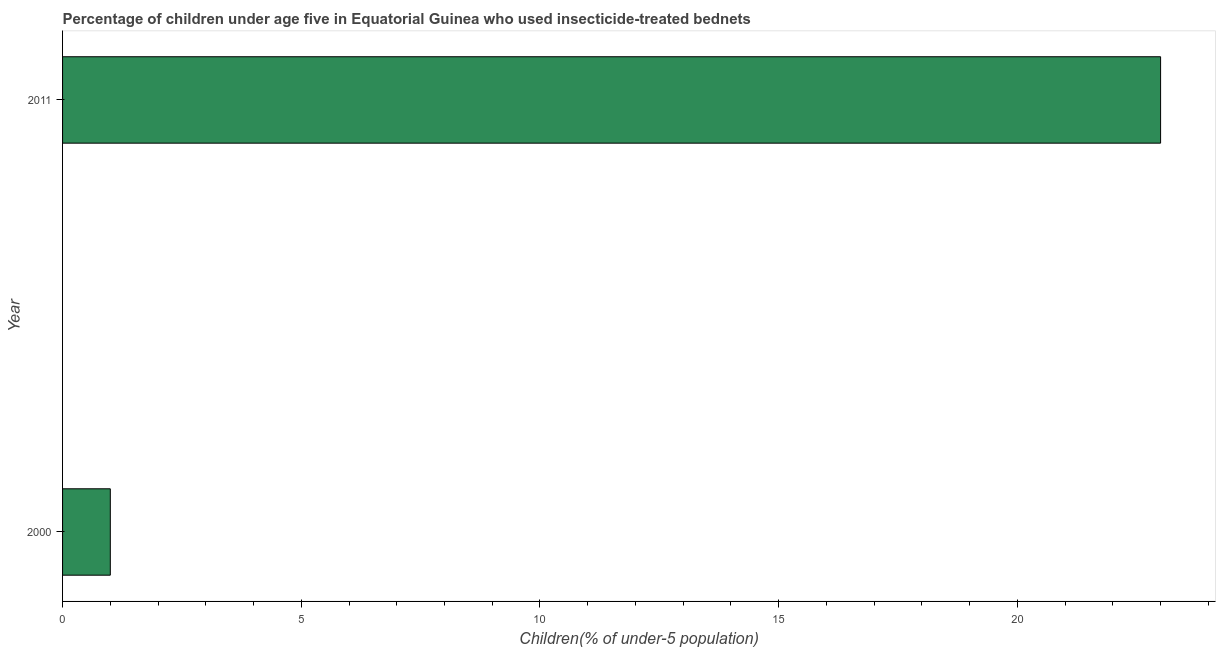What is the title of the graph?
Keep it short and to the point. Percentage of children under age five in Equatorial Guinea who used insecticide-treated bednets. What is the label or title of the X-axis?
Provide a succinct answer. Children(% of under-5 population). What is the percentage of children who use of insecticide-treated bed nets in 2000?
Your answer should be compact. 1. In which year was the percentage of children who use of insecticide-treated bed nets maximum?
Keep it short and to the point. 2011. In which year was the percentage of children who use of insecticide-treated bed nets minimum?
Provide a succinct answer. 2000. What is the difference between the percentage of children who use of insecticide-treated bed nets in 2000 and 2011?
Your answer should be very brief. -22. What is the median percentage of children who use of insecticide-treated bed nets?
Provide a succinct answer. 12. In how many years, is the percentage of children who use of insecticide-treated bed nets greater than 9 %?
Provide a succinct answer. 1. Do a majority of the years between 2000 and 2011 (inclusive) have percentage of children who use of insecticide-treated bed nets greater than 19 %?
Provide a short and direct response. No. What is the ratio of the percentage of children who use of insecticide-treated bed nets in 2000 to that in 2011?
Your answer should be very brief. 0.04. In how many years, is the percentage of children who use of insecticide-treated bed nets greater than the average percentage of children who use of insecticide-treated bed nets taken over all years?
Offer a very short reply. 1. Are the values on the major ticks of X-axis written in scientific E-notation?
Your response must be concise. No. What is the difference between the Children(% of under-5 population) in 2000 and 2011?
Your response must be concise. -22. What is the ratio of the Children(% of under-5 population) in 2000 to that in 2011?
Your answer should be very brief. 0.04. 